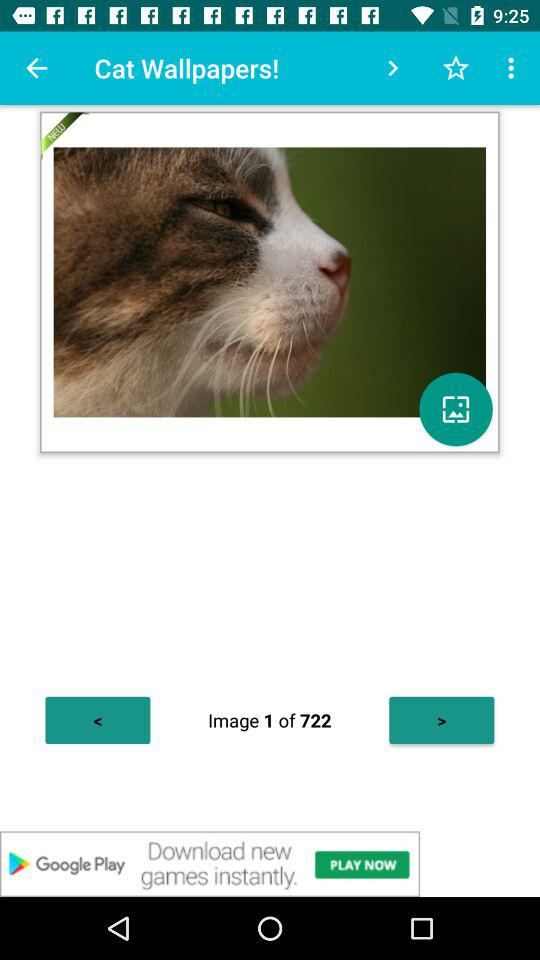What is the total count of images? The total count of images is 722. 